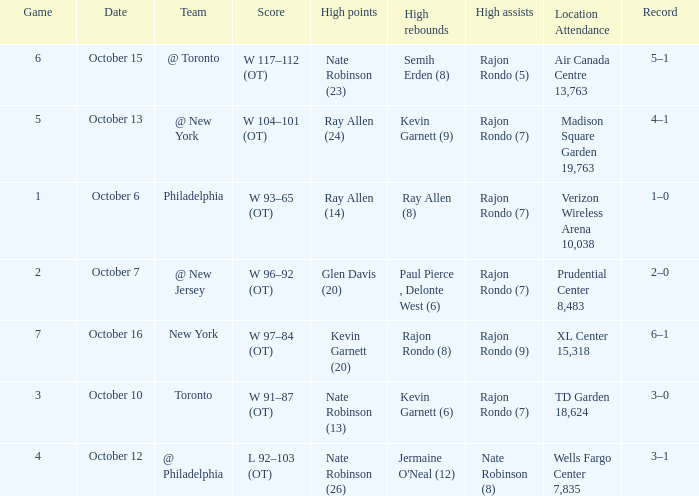Who had the most assists and how many did they have on October 7?  Rajon Rondo (7). 